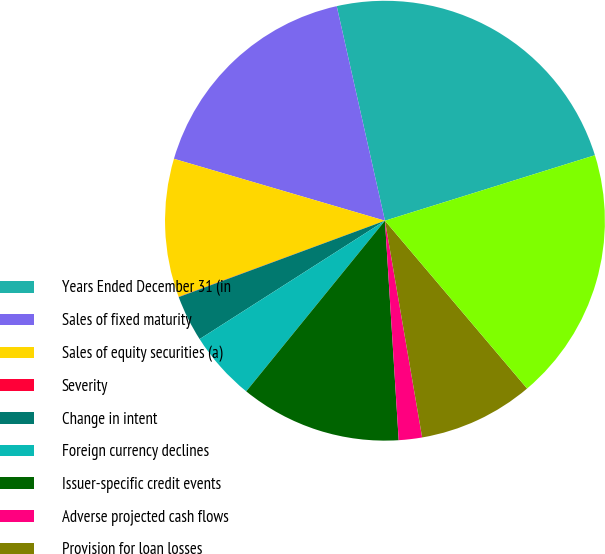Convert chart to OTSL. <chart><loc_0><loc_0><loc_500><loc_500><pie_chart><fcel>Years Ended December 31 (in<fcel>Sales of fixed maturity<fcel>Sales of equity securities (a)<fcel>Severity<fcel>Change in intent<fcel>Foreign currency declines<fcel>Issuer-specific credit events<fcel>Adverse projected cash flows<fcel>Provision for loan losses<fcel>Foreign exchange transactions<nl><fcel>23.71%<fcel>16.94%<fcel>10.17%<fcel>0.02%<fcel>3.4%<fcel>5.09%<fcel>11.86%<fcel>1.71%<fcel>8.48%<fcel>18.63%<nl></chart> 